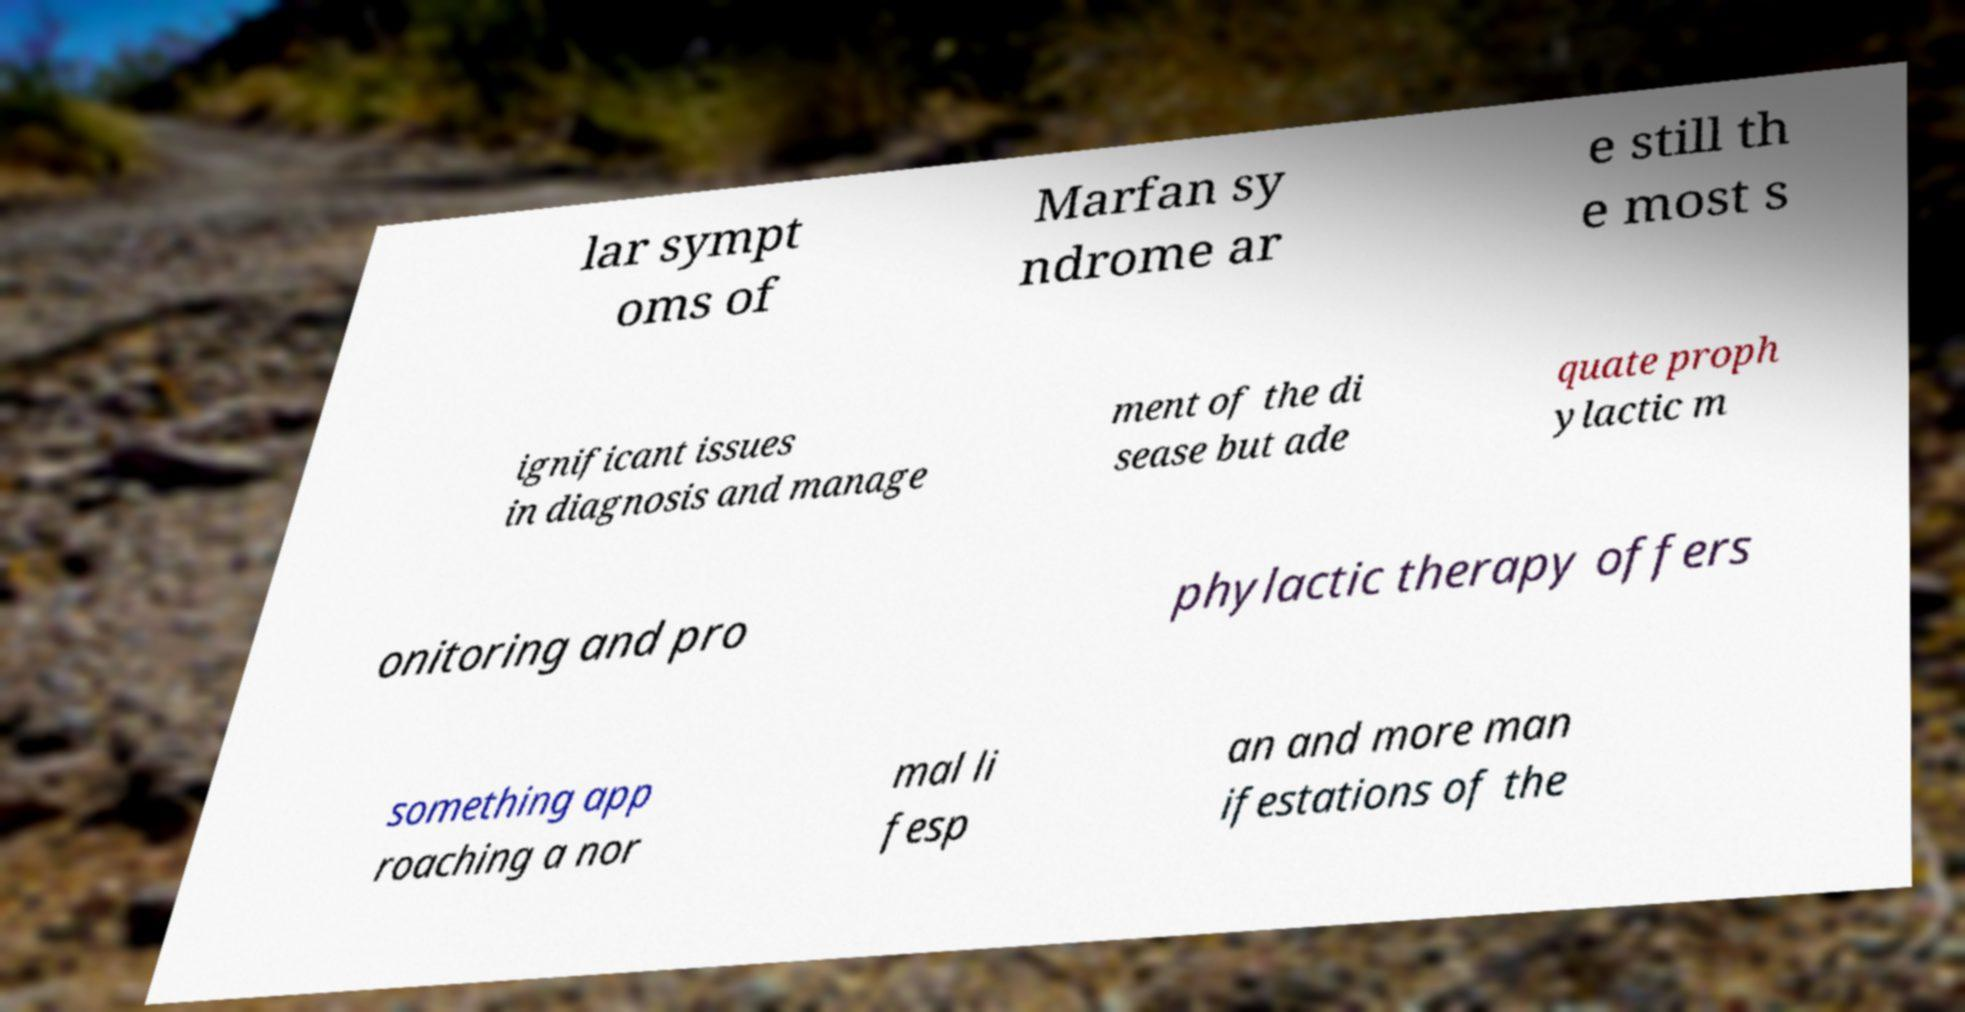I need the written content from this picture converted into text. Can you do that? lar sympt oms of Marfan sy ndrome ar e still th e most s ignificant issues in diagnosis and manage ment of the di sease but ade quate proph ylactic m onitoring and pro phylactic therapy offers something app roaching a nor mal li fesp an and more man ifestations of the 